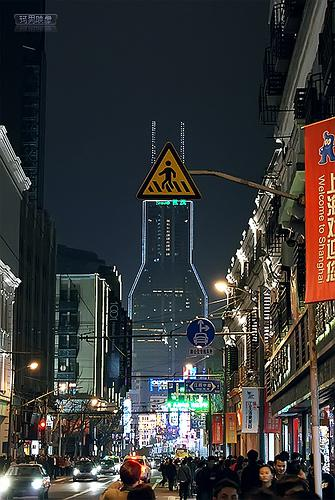Question: what does the welcome sign say?
Choices:
A. Welcome to Shanghai.
B. Welcome to Vancouver.
C. Welcome to Springfield.
D. Welcome to Des Moines.
Answer with the letter. Answer: A Question: how many red signs are there?
Choices:
A. 1.
B. 2.
C. 5.
D. 0.
Answer with the letter. Answer: A Question: what time of day is this photo taken?
Choices:
A. Morning.
B. Midday.
C. Evening.
D. Dusk.
Answer with the letter. Answer: C Question: what are the people doing?
Choices:
A. Going for a jog.
B. Standing in line for ice cream.
C. Sitting around talking.
D. Walking down the street.
Answer with the letter. Answer: D 